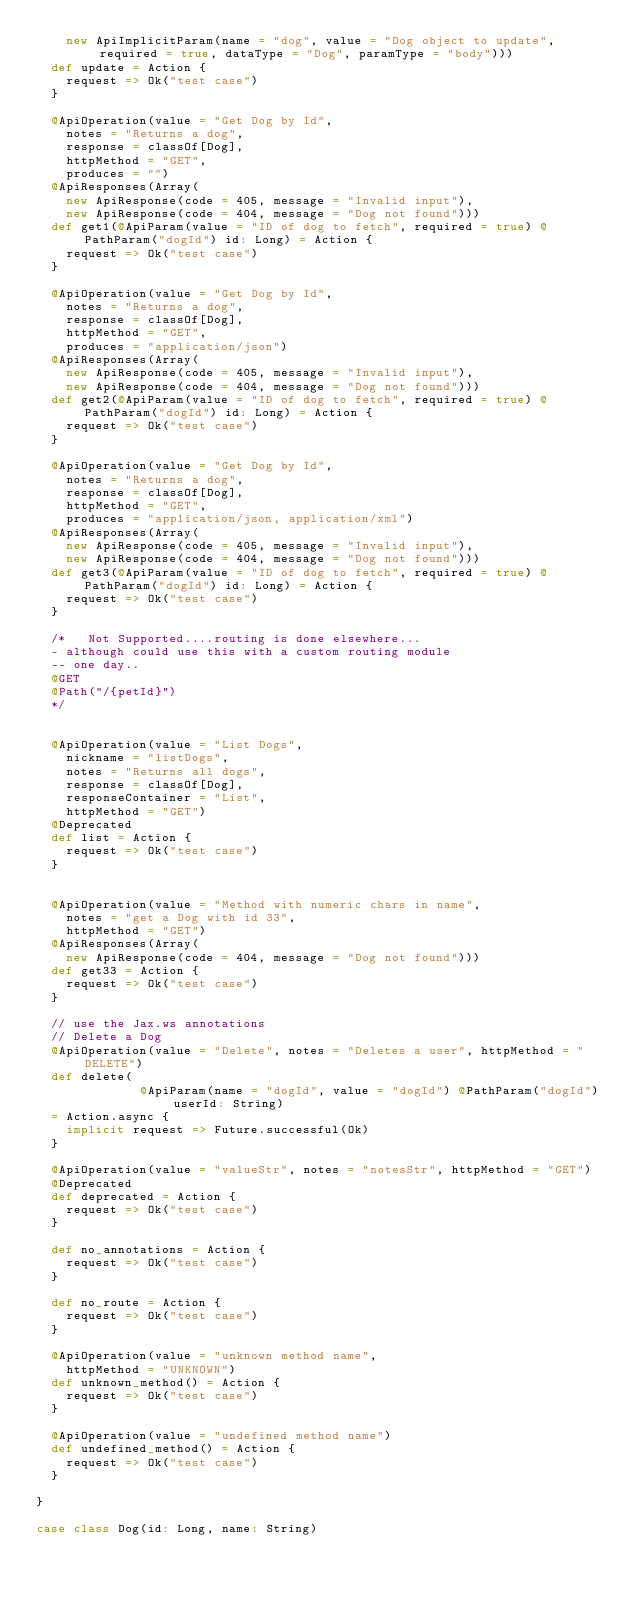Convert code to text. <code><loc_0><loc_0><loc_500><loc_500><_Scala_>    new ApiImplicitParam(name = "dog", value = "Dog object to update", required = true, dataType = "Dog", paramType = "body")))
  def update = Action {
    request => Ok("test case")
  }

  @ApiOperation(value = "Get Dog by Id",
    notes = "Returns a dog",
    response = classOf[Dog],
    httpMethod = "GET",
    produces = "")
  @ApiResponses(Array(
    new ApiResponse(code = 405, message = "Invalid input"),
    new ApiResponse(code = 404, message = "Dog not found")))
  def get1(@ApiParam(value = "ID of dog to fetch", required = true) @PathParam("dogId") id: Long) = Action {
    request => Ok("test case")
  }

  @ApiOperation(value = "Get Dog by Id",
    notes = "Returns a dog",
    response = classOf[Dog],
    httpMethod = "GET",
    produces = "application/json")
  @ApiResponses(Array(
    new ApiResponse(code = 405, message = "Invalid input"),
    new ApiResponse(code = 404, message = "Dog not found")))
  def get2(@ApiParam(value = "ID of dog to fetch", required = true) @PathParam("dogId") id: Long) = Action {
    request => Ok("test case")
  }

  @ApiOperation(value = "Get Dog by Id",
    notes = "Returns a dog",
    response = classOf[Dog],
    httpMethod = "GET",
    produces = "application/json, application/xml")
  @ApiResponses(Array(
    new ApiResponse(code = 405, message = "Invalid input"),
    new ApiResponse(code = 404, message = "Dog not found")))
  def get3(@ApiParam(value = "ID of dog to fetch", required = true) @PathParam("dogId") id: Long) = Action {
    request => Ok("test case")
  }

  /*   Not Supported....routing is done elsewhere...
  - although could use this with a custom routing module
  -- one day..
  @GET
  @Path("/{petId}")
  */


  @ApiOperation(value = "List Dogs",
    nickname = "listDogs",
    notes = "Returns all dogs",
    response = classOf[Dog],
    responseContainer = "List",
    httpMethod = "GET")
  @Deprecated
  def list = Action {
    request => Ok("test case")
  }


  @ApiOperation(value = "Method with numeric chars in name",
    notes = "get a Dog with id 33",
    httpMethod = "GET")
  @ApiResponses(Array(
    new ApiResponse(code = 404, message = "Dog not found")))
  def get33 = Action {
    request => Ok("test case")
  }

  // use the Jax.ws annotations
  // Delete a Dog
  @ApiOperation(value = "Delete", notes = "Deletes a user", httpMethod = "DELETE")
  def delete(
              @ApiParam(name = "dogId", value = "dogId") @PathParam("dogId") userId: String)
  = Action.async {
    implicit request => Future.successful(Ok)
  }

  @ApiOperation(value = "valueStr", notes = "notesStr", httpMethod = "GET")
  @Deprecated
  def deprecated = Action {
    request => Ok("test case")
  }

  def no_annotations = Action {
    request => Ok("test case")
  }

  def no_route = Action {
    request => Ok("test case")
  }

  @ApiOperation(value = "unknown method name",
    httpMethod = "UNKNOWN")
  def unknown_method() = Action {
    request => Ok("test case")
  }

  @ApiOperation(value = "undefined method name")
  def undefined_method() = Action {
    request => Ok("test case")
  }

}

case class Dog(id: Long, name: String)
</code> 